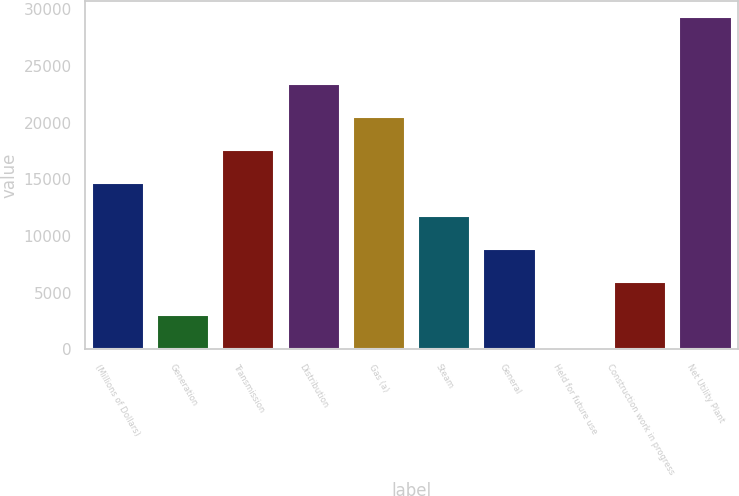<chart> <loc_0><loc_0><loc_500><loc_500><bar_chart><fcel>(Millions of Dollars)<fcel>Generation<fcel>Transmission<fcel>Distribution<fcel>Gas (a)<fcel>Steam<fcel>General<fcel>Held for future use<fcel>Construction work in progress<fcel>Net Utility Plant<nl><fcel>14687.5<fcel>2989.5<fcel>17612<fcel>23461<fcel>20536.5<fcel>11763<fcel>8838.5<fcel>65<fcel>5914<fcel>29310<nl></chart> 